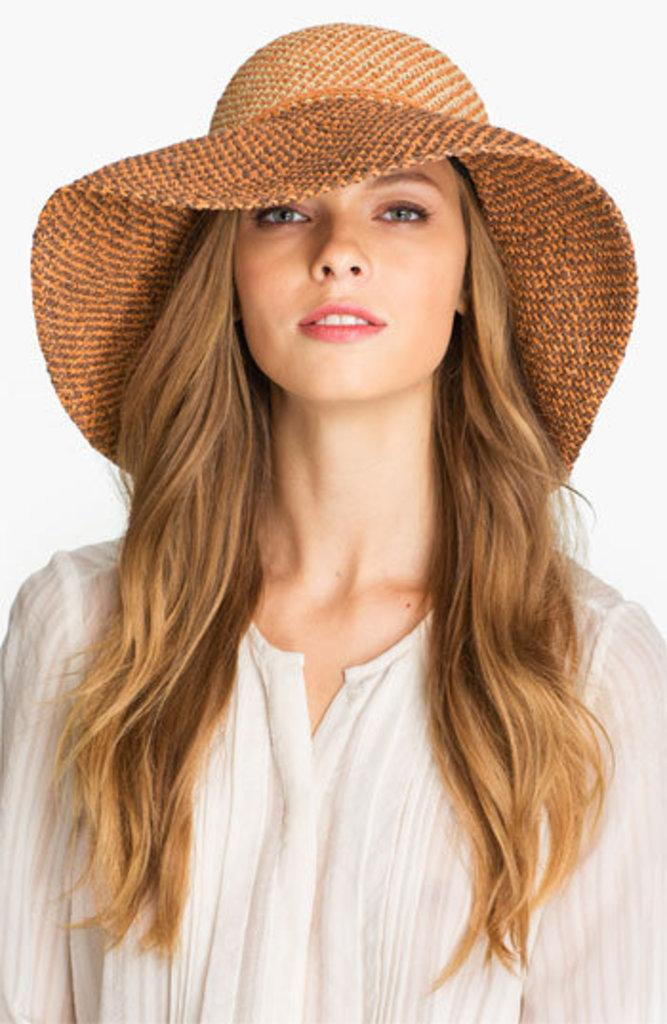What is the main subject of the image? There is a person in the image. What is the person wearing on their upper body? The person is wearing a cream-colored shirt. What type of headwear is the person wearing? The person is wearing a brown-colored hat. What color is the background of the image? The background of the image is white. What type of muscle is visible on the person's face in the image? There is no muscle visible on the person's face in the image. What is the person doing during the war in the image? There is no war or any indication of conflict in the image. 